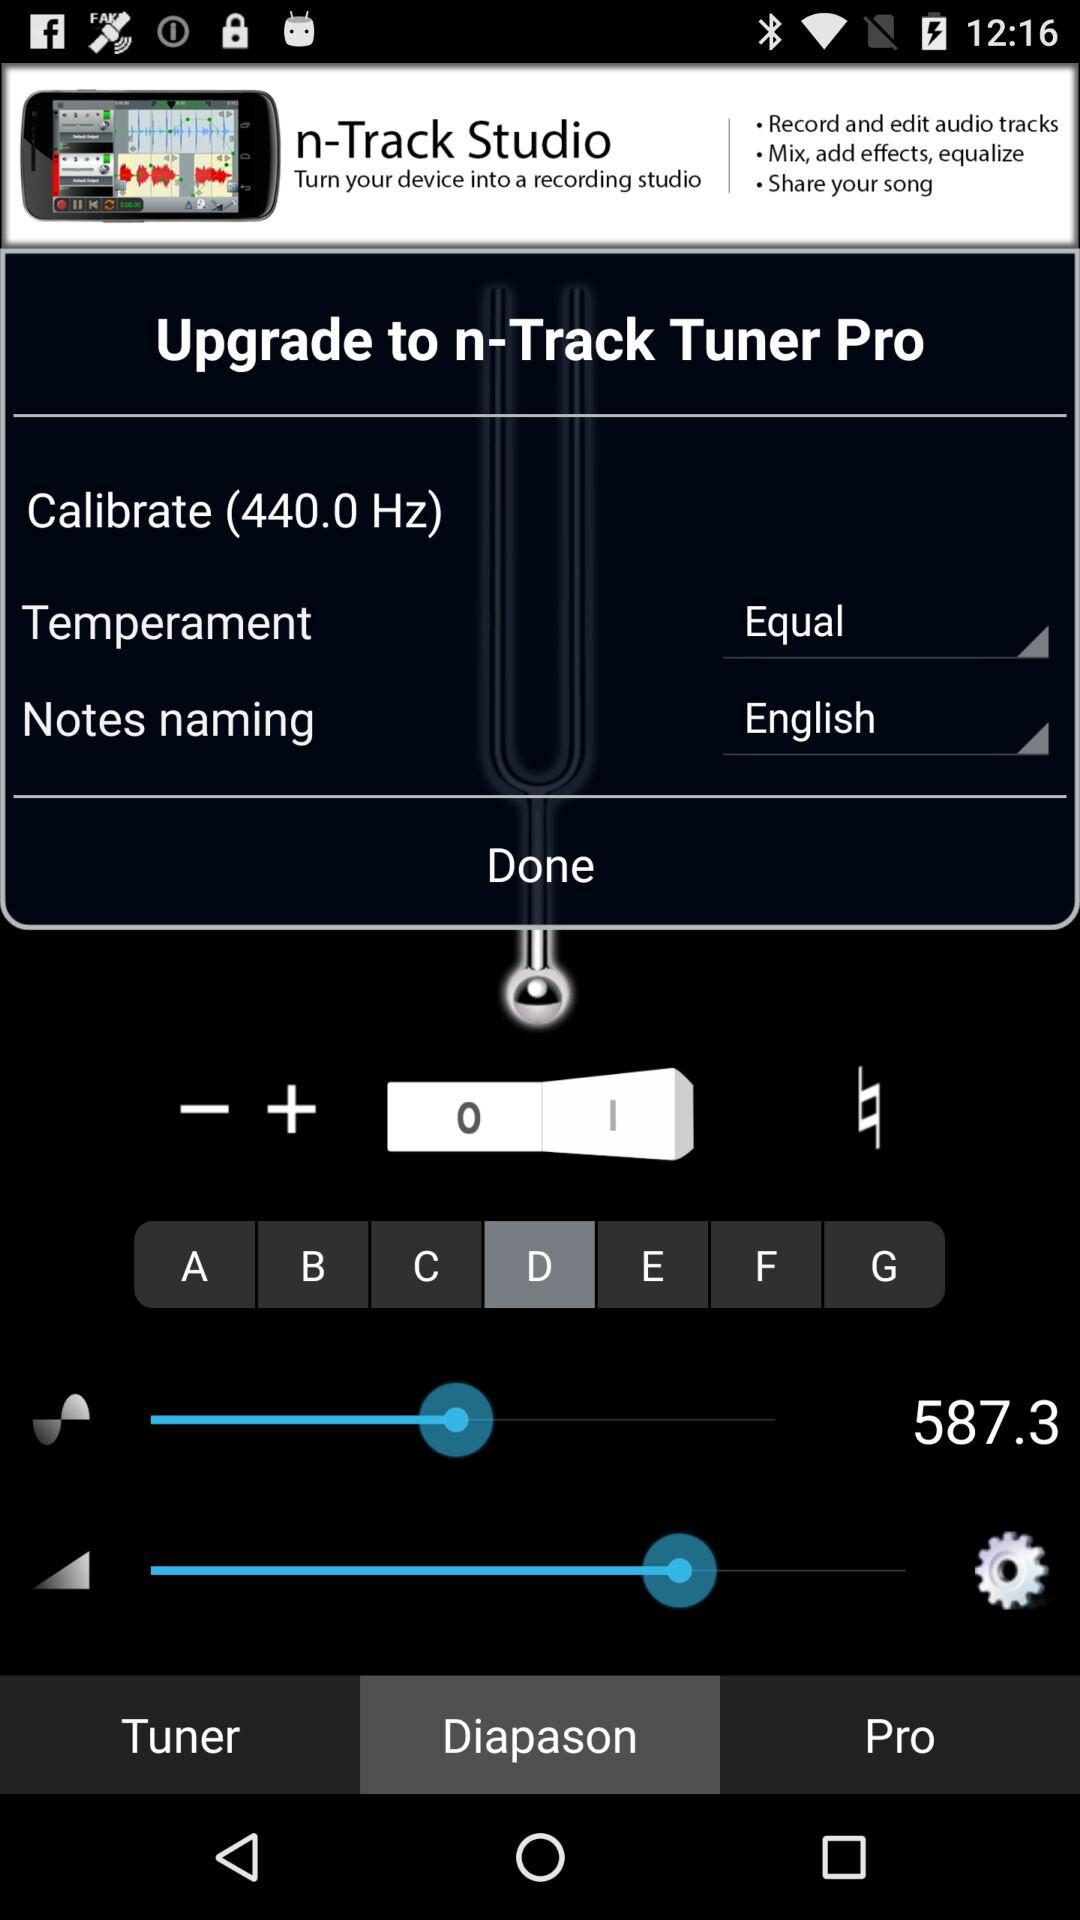What is the "Temperament"? The temperament is "Equal". 